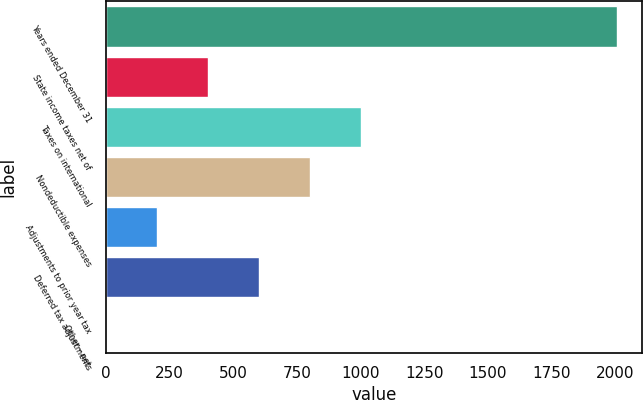Convert chart to OTSL. <chart><loc_0><loc_0><loc_500><loc_500><bar_chart><fcel>Years ended December 31<fcel>State income taxes net of<fcel>Taxes on international<fcel>Nondeductible expenses<fcel>Adjustments to prior year tax<fcel>Deferred tax adjustments<fcel>Other - net<nl><fcel>2007<fcel>401.88<fcel>1003.8<fcel>803.16<fcel>201.24<fcel>602.52<fcel>0.6<nl></chart> 